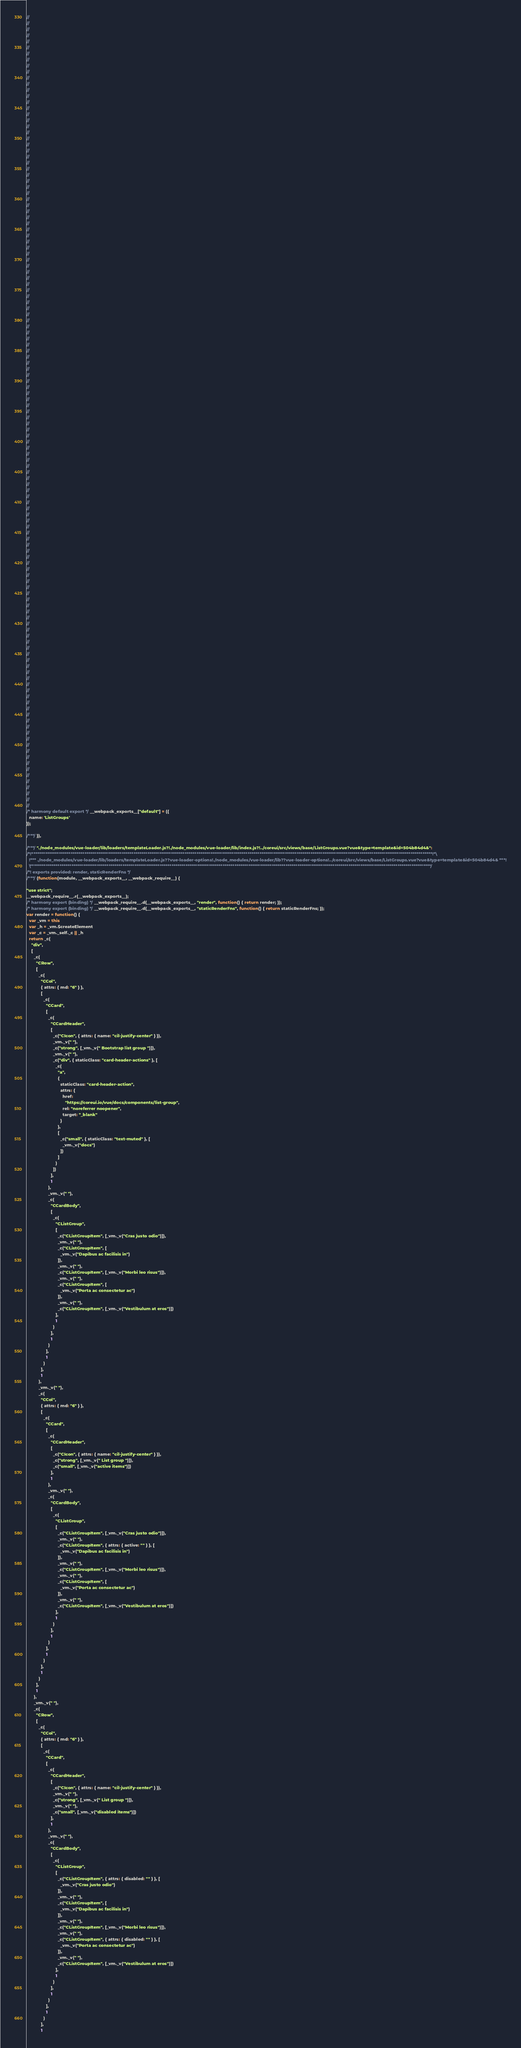Convert code to text. <code><loc_0><loc_0><loc_500><loc_500><_JavaScript_>//
//
//
//
//
//
//
//
//
//
//
//
//
//
//
//
//
//
//
//
//
//
//
//
//
//
//
//
//
//
//
//
//
//
//
//
//
//
//
//
//
//
//
//
//
//
//
//
//
//
//
//
//
//
//
//
//
//
//
//
//
//
//
//
//
//
//
//
//
//
//
//
//
//
//
//
//
//
//
//
//
//
//
//
//
//
//
//
//
//
//
//
//
//
//
//
//
//
//
//
//
//
//
//
//
//
//
//
//
//
//
//
//
//
//
//
//
//
//
//
//
//
//
//
//
//
//
//
//
//
//
/* harmony default export */ __webpack_exports__["default"] = ({
  name: 'ListGroups'
});

/***/ }),

/***/ "./node_modules/vue-loader/lib/loaders/templateLoader.js?!./node_modules/vue-loader/lib/index.js?!../coreui/src/views/base/ListGroups.vue?vue&type=template&id=504b84d4&":
/*!************************************************************************************************************************************************************************************************************!*\
  !*** ./node_modules/vue-loader/lib/loaders/templateLoader.js??vue-loader-options!./node_modules/vue-loader/lib??vue-loader-options!../coreui/src/views/base/ListGroups.vue?vue&type=template&id=504b84d4& ***!
  \************************************************************************************************************************************************************************************************************/
/*! exports provided: render, staticRenderFns */
/***/ (function(module, __webpack_exports__, __webpack_require__) {

"use strict";
__webpack_require__.r(__webpack_exports__);
/* harmony export (binding) */ __webpack_require__.d(__webpack_exports__, "render", function() { return render; });
/* harmony export (binding) */ __webpack_require__.d(__webpack_exports__, "staticRenderFns", function() { return staticRenderFns; });
var render = function() {
  var _vm = this
  var _h = _vm.$createElement
  var _c = _vm._self._c || _h
  return _c(
    "div",
    [
      _c(
        "CRow",
        [
          _c(
            "CCol",
            { attrs: { md: "6" } },
            [
              _c(
                "CCard",
                [
                  _c(
                    "CCardHeader",
                    [
                      _c("CIcon", { attrs: { name: "cil-justify-center" } }),
                      _vm._v(" "),
                      _c("strong", [_vm._v(" Bootstrap list group ")]),
                      _vm._v(" "),
                      _c("div", { staticClass: "card-header-actions" }, [
                        _c(
                          "a",
                          {
                            staticClass: "card-header-action",
                            attrs: {
                              href:
                                "https://coreui.io/vue/docs/components/list-group",
                              rel: "noreferrer noopener",
                              target: "_blank"
                            }
                          },
                          [
                            _c("small", { staticClass: "text-muted" }, [
                              _vm._v("docs")
                            ])
                          ]
                        )
                      ])
                    ],
                    1
                  ),
                  _vm._v(" "),
                  _c(
                    "CCardBody",
                    [
                      _c(
                        "CListGroup",
                        [
                          _c("CListGroupItem", [_vm._v("Cras justo odio")]),
                          _vm._v(" "),
                          _c("CListGroupItem", [
                            _vm._v("Dapibus ac facilisis in")
                          ]),
                          _vm._v(" "),
                          _c("CListGroupItem", [_vm._v("Morbi leo risus")]),
                          _vm._v(" "),
                          _c("CListGroupItem", [
                            _vm._v("Porta ac consectetur ac")
                          ]),
                          _vm._v(" "),
                          _c("CListGroupItem", [_vm._v("Vestibulum at eros")])
                        ],
                        1
                      )
                    ],
                    1
                  )
                ],
                1
              )
            ],
            1
          ),
          _vm._v(" "),
          _c(
            "CCol",
            { attrs: { md: "6" } },
            [
              _c(
                "CCard",
                [
                  _c(
                    "CCardHeader",
                    [
                      _c("CIcon", { attrs: { name: "cil-justify-center" } }),
                      _c("strong", [_vm._v(" List group ")]),
                      _c("small", [_vm._v("active items")])
                    ],
                    1
                  ),
                  _vm._v(" "),
                  _c(
                    "CCardBody",
                    [
                      _c(
                        "CListGroup",
                        [
                          _c("CListGroupItem", [_vm._v("Cras justo odio")]),
                          _vm._v(" "),
                          _c("CListGroupItem", { attrs: { active: "" } }, [
                            _vm._v("Dapibus ac facilisis in")
                          ]),
                          _vm._v(" "),
                          _c("CListGroupItem", [_vm._v("Morbi leo risus")]),
                          _vm._v(" "),
                          _c("CListGroupItem", [
                            _vm._v("Porta ac consectetur ac")
                          ]),
                          _vm._v(" "),
                          _c("CListGroupItem", [_vm._v("Vestibulum at eros")])
                        ],
                        1
                      )
                    ],
                    1
                  )
                ],
                1
              )
            ],
            1
          )
        ],
        1
      ),
      _vm._v(" "),
      _c(
        "CRow",
        [
          _c(
            "CCol",
            { attrs: { md: "6" } },
            [
              _c(
                "CCard",
                [
                  _c(
                    "CCardHeader",
                    [
                      _c("CIcon", { attrs: { name: "cil-justify-center" } }),
                      _vm._v(" "),
                      _c("strong", [_vm._v(" List group ")]),
                      _vm._v(" "),
                      _c("small", [_vm._v("disabled items")])
                    ],
                    1
                  ),
                  _vm._v(" "),
                  _c(
                    "CCardBody",
                    [
                      _c(
                        "CListGroup",
                        [
                          _c("CListGroupItem", { attrs: { disabled: "" } }, [
                            _vm._v("Cras justo odio")
                          ]),
                          _vm._v(" "),
                          _c("CListGroupItem", [
                            _vm._v("Dapibus ac facilisis in")
                          ]),
                          _vm._v(" "),
                          _c("CListGroupItem", [_vm._v("Morbi leo risus")]),
                          _vm._v(" "),
                          _c("CListGroupItem", { attrs: { disabled: "" } }, [
                            _vm._v("Porta ac consectetur ac")
                          ]),
                          _vm._v(" "),
                          _c("CListGroupItem", [_vm._v("Vestibulum at eros")])
                        ],
                        1
                      )
                    ],
                    1
                  )
                ],
                1
              )
            ],
            1</code> 